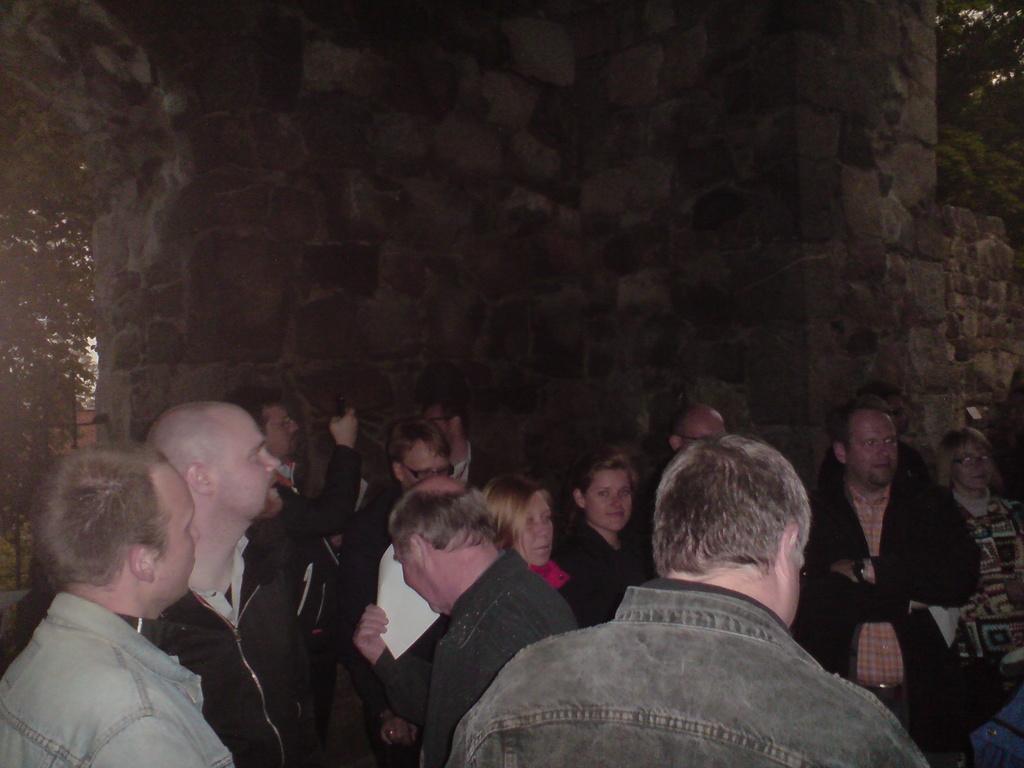Could you give a brief overview of what you see in this image? In this image we can see a group of persons. Behind the persons we can see a wall. On the left side, we can see a tree. In the top right, we can see another tree. 